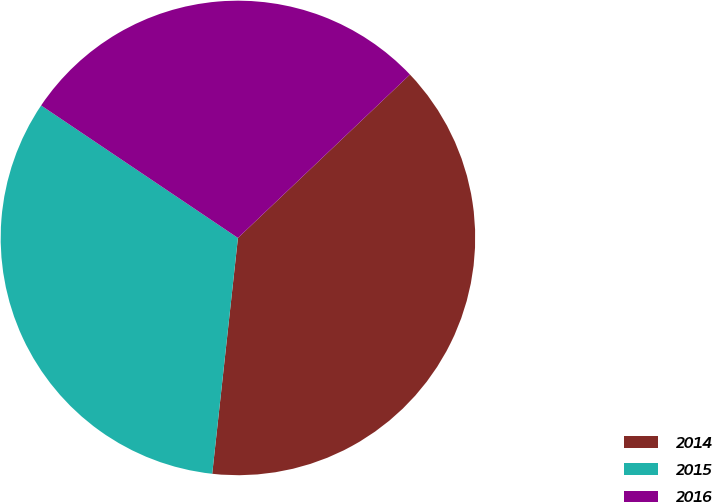<chart> <loc_0><loc_0><loc_500><loc_500><pie_chart><fcel>2014<fcel>2015<fcel>2016<nl><fcel>38.82%<fcel>32.7%<fcel>28.48%<nl></chart> 